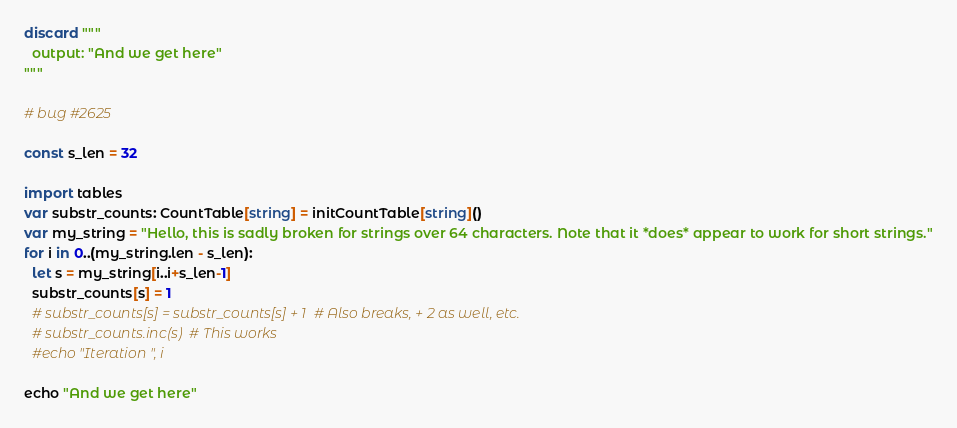<code> <loc_0><loc_0><loc_500><loc_500><_Nim_>discard """
  output: "And we get here"
"""

# bug #2625

const s_len = 32

import tables
var substr_counts: CountTable[string] = initCountTable[string]()
var my_string = "Hello, this is sadly broken for strings over 64 characters. Note that it *does* appear to work for short strings."
for i in 0..(my_string.len - s_len):
  let s = my_string[i..i+s_len-1]
  substr_counts[s] = 1
  # substr_counts[s] = substr_counts[s] + 1  # Also breaks, + 2 as well, etc.
  # substr_counts.inc(s)  # This works
  #echo "Iteration ", i

echo "And we get here"
</code> 